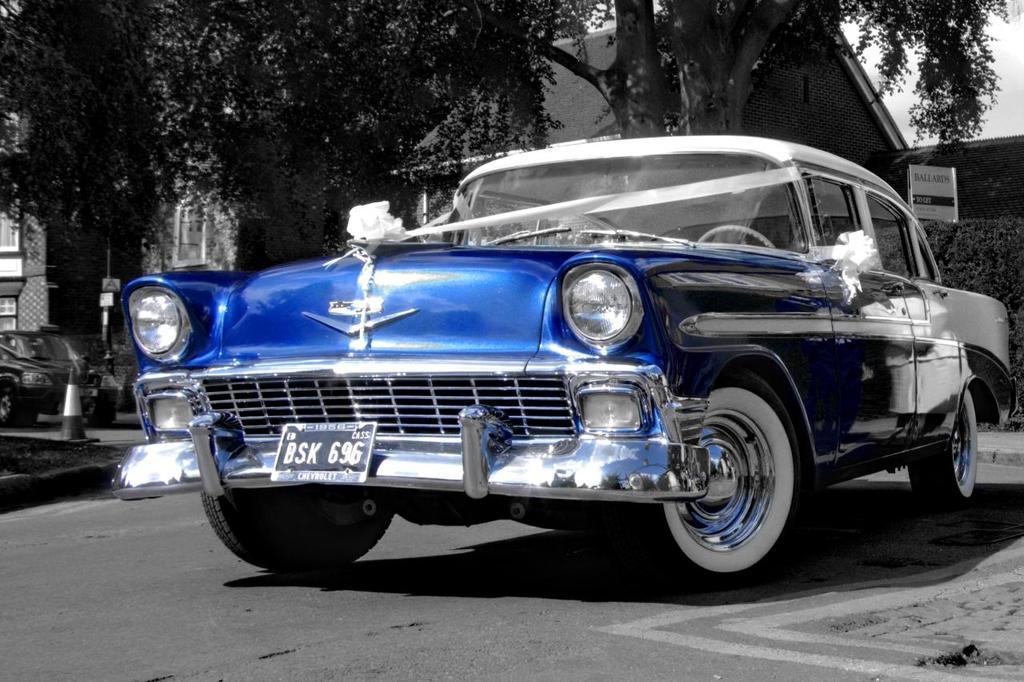How would you summarize this image in a sentence or two? In this image we can see motor vehicle on the road, buildings, traffic cones, information boards, bushes, trees and sky. 